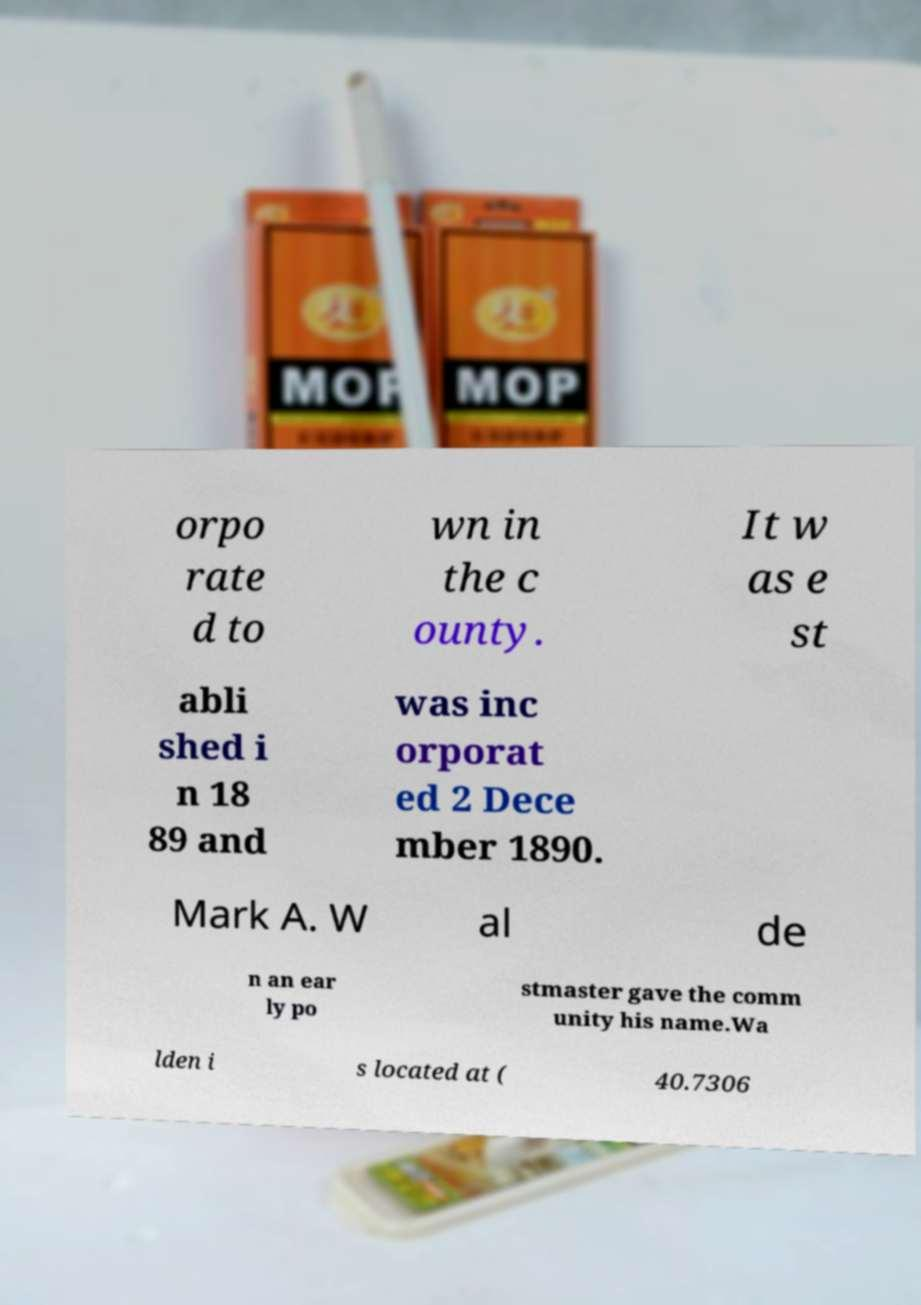Could you extract and type out the text from this image? orpo rate d to wn in the c ounty. It w as e st abli shed i n 18 89 and was inc orporat ed 2 Dece mber 1890. Mark A. W al de n an ear ly po stmaster gave the comm unity his name.Wa lden i s located at ( 40.7306 